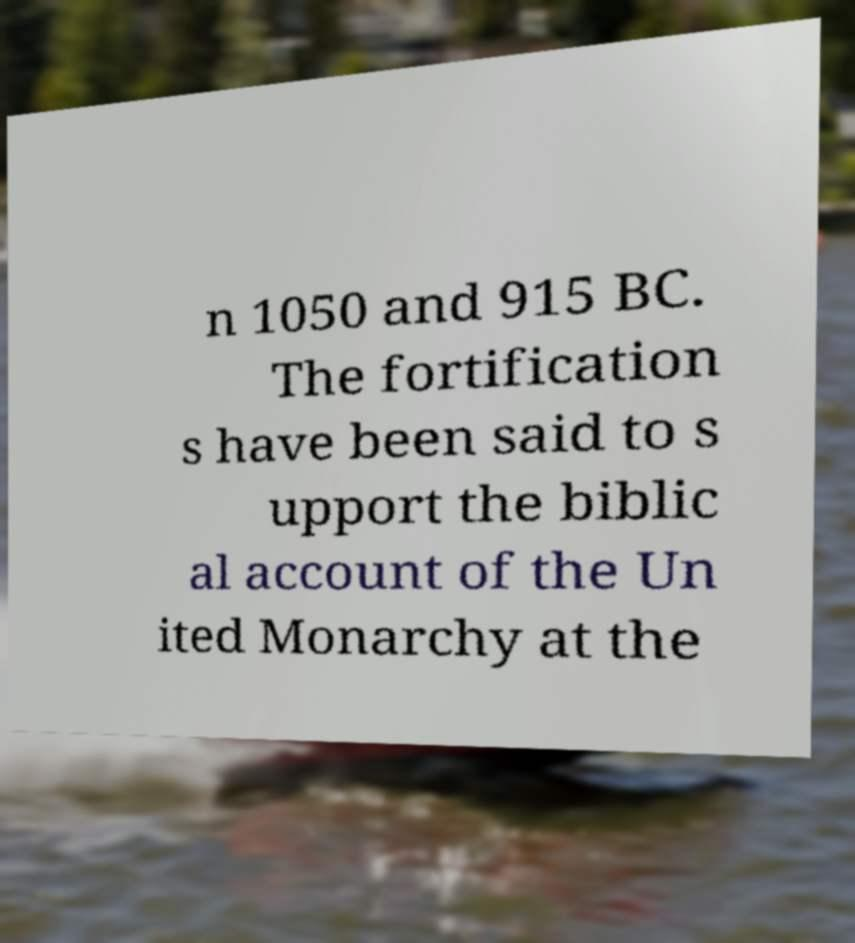Can you read and provide the text displayed in the image?This photo seems to have some interesting text. Can you extract and type it out for me? n 1050 and 915 BC. The fortification s have been said to s upport the biblic al account of the Un ited Monarchy at the 